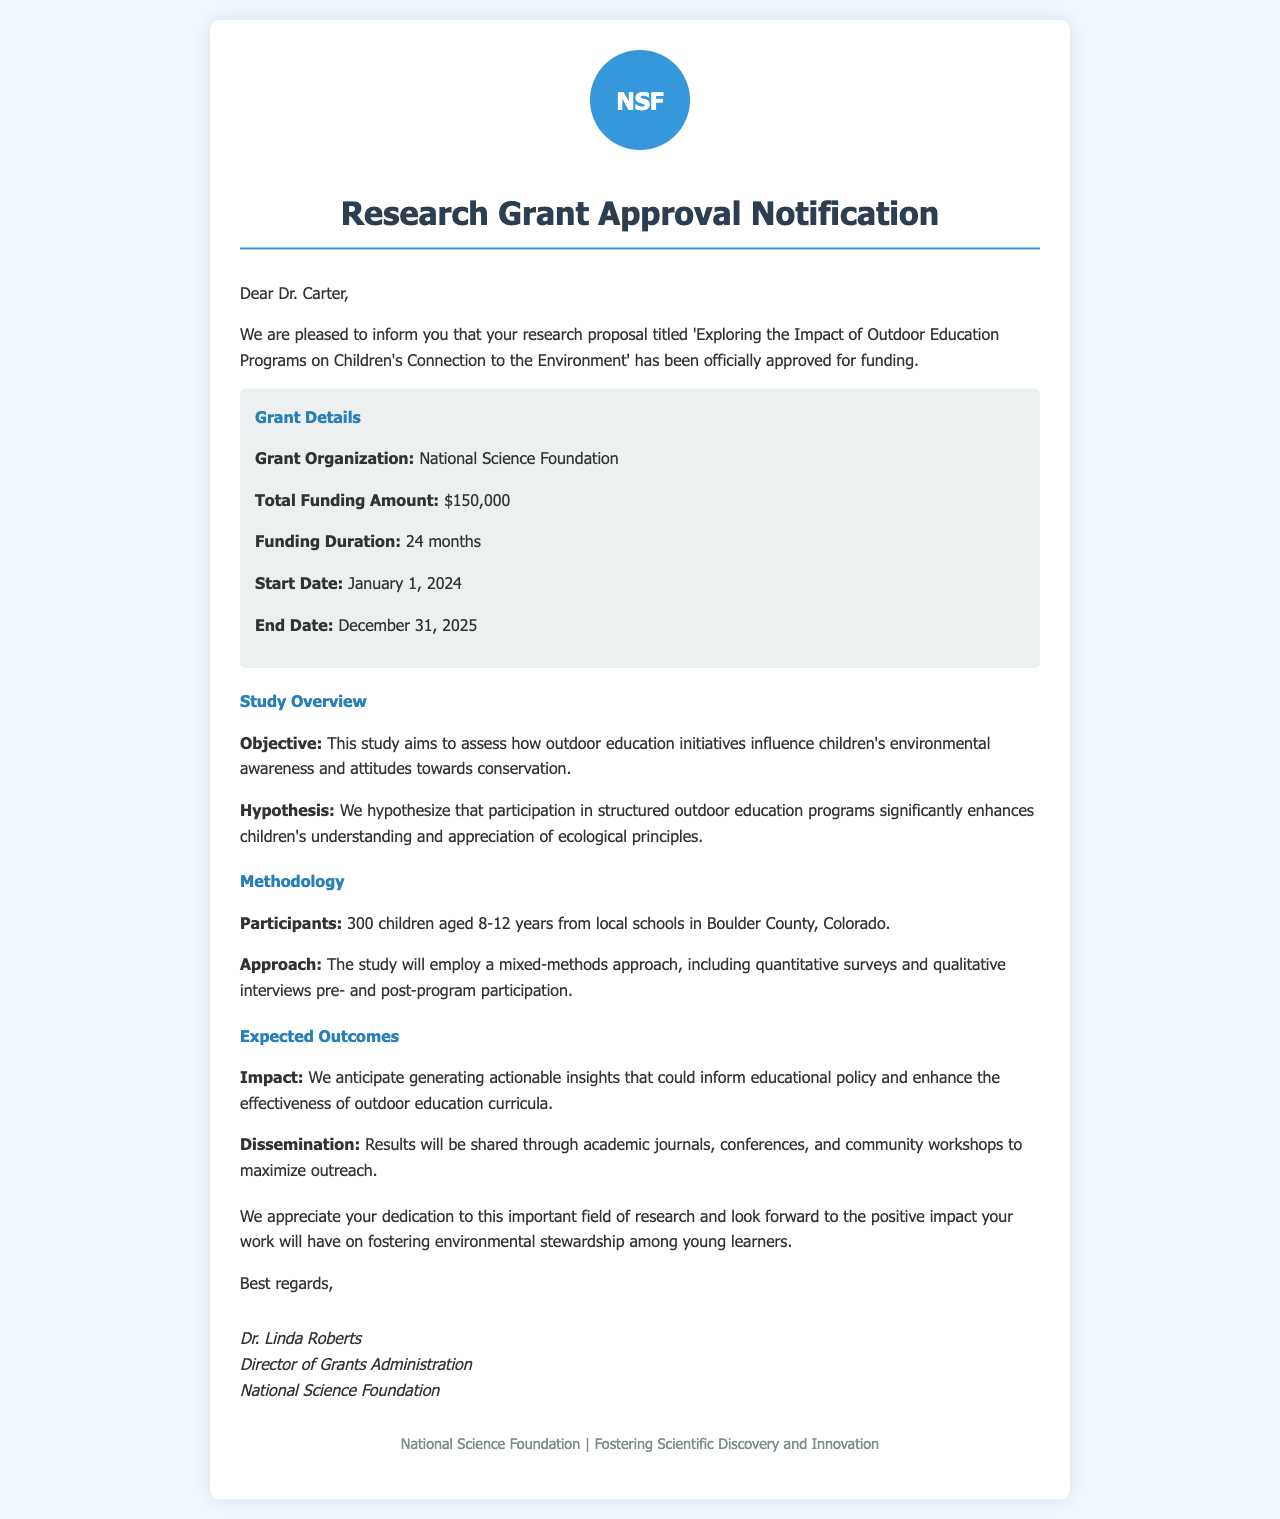What is the title of the research proposal? The title of the research proposal is found in the document's introduction.
Answer: Exploring the Impact of Outdoor Education Programs on Children's Connection to the Environment Who is the grant organization providing funding? The grant organization is mentioned in the grant details section of the document.
Answer: National Science Foundation What is the total funding amount approved? The total funding amount is stated within the grant details section.
Answer: $150,000 How long is the funding duration? The funding duration is detailed in the grant details section of the document.
Answer: 24 months What is the start date of the funding? The start date is specified in the grant details section.
Answer: January 1, 2024 What are the expected outcomes of the study? The expected outcomes are summarized in the expected outcomes section of the document.
Answer: Actionable insights What is the hypothesis of the study? The hypothesis is outlined in the study overview section.
Answer: Participation in structured outdoor education programs significantly enhances children's understanding and appreciation of ecological principles How many children will participate in the study? The number of participants is mentioned in the methodology section.
Answer: 300 children What approach will be used in the study? The approach is described in the methodology section.
Answer: Mixed-methods approach Who signed the grant approval notification? The signer of the notification is listed in the signature section.
Answer: Dr. Linda Roberts 